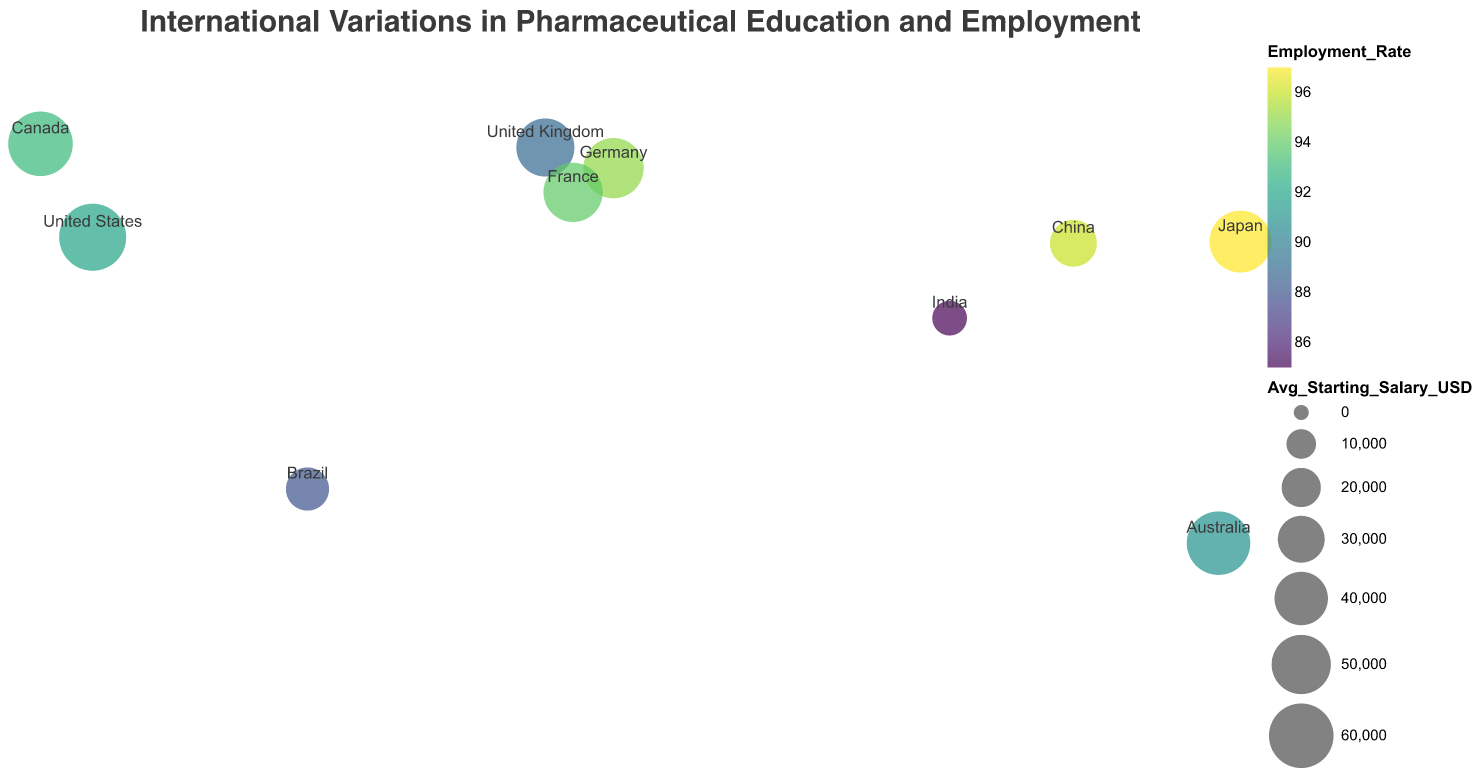What is the title of the figure? The title of the figure can be seen at the top and is a textual representation indicating the main focus of the plot.
Answer: International Variations in Pharmaceutical Education and Employment Which country has the highest employment rate? To determine the highest employment rate, look at the color shades in the figure representing the employment rate and also check the tooltip data for the highest percentage.
Answer: Japan How many countries have an education duration of 4 years? Count the number of countries labeled on the plot that have "Education_Duration" equal to 4.
Answer: 5 What is the average starting salary in the United States? Refer to the tooltip data that appears when hovering over the point representing the United States on the plot to see the average starting salary in USD.
Answer: 65000 Which country has the longest education duration in pharmaceutical sciences? Check for the highest value in the "Education_Duration" field among all the labeled countries in the plot.
Answer: Japan and France Between Australia and Brazil, which country has more practical training hours required? Compare the "Practical_Training_Hours" values for both Australia and Brazil as labeled on the plot.
Answer: Australia What is the difference in average starting salary between Canada and China? Identify the "Avg_Starting_Salary_USD" values for Canada and China, then subtract the smaller value from the larger value to find the difference.
Answer: 30000 USD Which country in the plot has the lowest average starting salary? Look for the smallest value in the "Avg_Starting_Salary_USD" field among all the points plotted.
Answer: India What is the average practical training hours for countries with an employment rate above 90%? First, identify the countries with an employment rate above 90%, then sum their practical training hours and divide by the number of these countries.
Answer: 1680 Are there any countries with both a 6-year education duration and an employment rate above 95%? If so, which? Check the "Education_Duration" and "Employment_Rate" fields to see if any country meets both criteria of 6 years for education duration and above 95% for employment rate.
Answer: Japan 